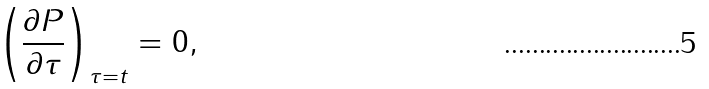Convert formula to latex. <formula><loc_0><loc_0><loc_500><loc_500>\left ( \frac { \partial P } { \partial \tau } \right ) _ { \tau = t } = 0 ,</formula> 